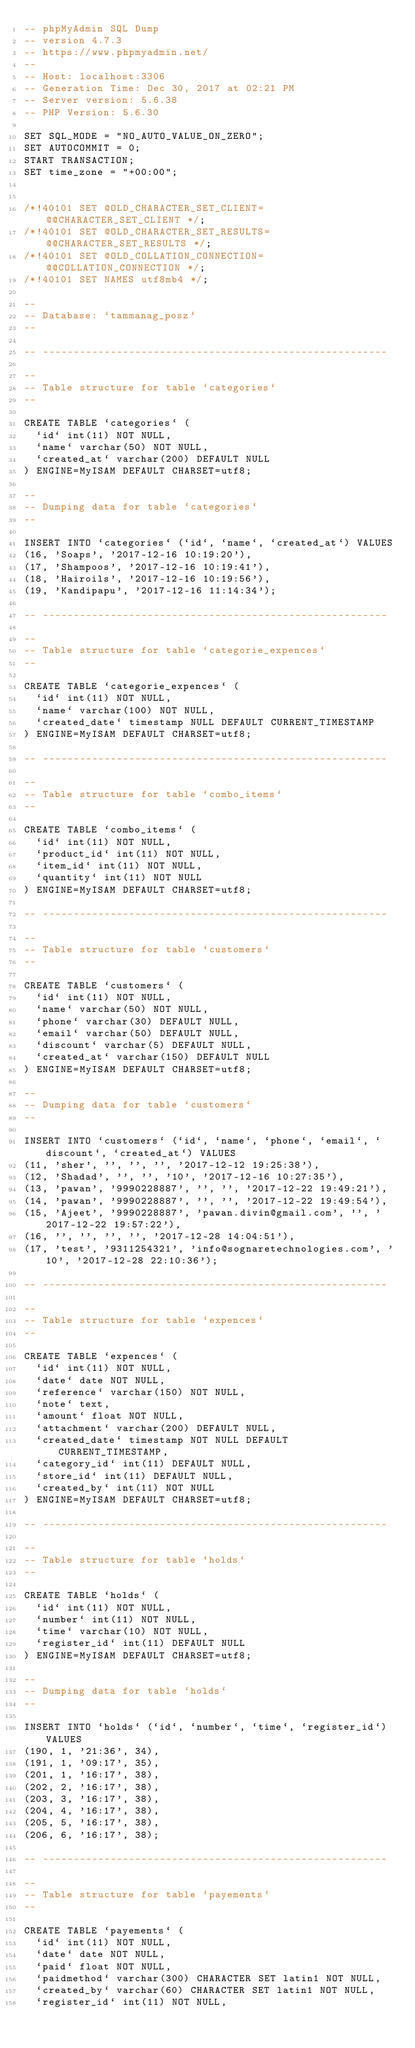<code> <loc_0><loc_0><loc_500><loc_500><_SQL_>-- phpMyAdmin SQL Dump
-- version 4.7.3
-- https://www.phpmyadmin.net/
--
-- Host: localhost:3306
-- Generation Time: Dec 30, 2017 at 02:21 PM
-- Server version: 5.6.38
-- PHP Version: 5.6.30

SET SQL_MODE = "NO_AUTO_VALUE_ON_ZERO";
SET AUTOCOMMIT = 0;
START TRANSACTION;
SET time_zone = "+00:00";


/*!40101 SET @OLD_CHARACTER_SET_CLIENT=@@CHARACTER_SET_CLIENT */;
/*!40101 SET @OLD_CHARACTER_SET_RESULTS=@@CHARACTER_SET_RESULTS */;
/*!40101 SET @OLD_COLLATION_CONNECTION=@@COLLATION_CONNECTION */;
/*!40101 SET NAMES utf8mb4 */;

--
-- Database: `tammanag_posz`
--

-- --------------------------------------------------------

--
-- Table structure for table `categories`
--

CREATE TABLE `categories` (
  `id` int(11) NOT NULL,
  `name` varchar(50) NOT NULL,
  `created_at` varchar(200) DEFAULT NULL
) ENGINE=MyISAM DEFAULT CHARSET=utf8;

--
-- Dumping data for table `categories`
--

INSERT INTO `categories` (`id`, `name`, `created_at`) VALUES
(16, 'Soaps', '2017-12-16 10:19:20'),
(17, 'Shampoos', '2017-12-16 10:19:41'),
(18, 'Hairoils', '2017-12-16 10:19:56'),
(19, 'Kandipapu', '2017-12-16 11:14:34');

-- --------------------------------------------------------

--
-- Table structure for table `categorie_expences`
--

CREATE TABLE `categorie_expences` (
  `id` int(11) NOT NULL,
  `name` varchar(100) NOT NULL,
  `created_date` timestamp NULL DEFAULT CURRENT_TIMESTAMP
) ENGINE=MyISAM DEFAULT CHARSET=utf8;

-- --------------------------------------------------------

--
-- Table structure for table `combo_items`
--

CREATE TABLE `combo_items` (
  `id` int(11) NOT NULL,
  `product_id` int(11) NOT NULL,
  `item_id` int(11) NOT NULL,
  `quantity` int(11) NOT NULL
) ENGINE=MyISAM DEFAULT CHARSET=utf8;

-- --------------------------------------------------------

--
-- Table structure for table `customers`
--

CREATE TABLE `customers` (
  `id` int(11) NOT NULL,
  `name` varchar(50) NOT NULL,
  `phone` varchar(30) DEFAULT NULL,
  `email` varchar(50) DEFAULT NULL,
  `discount` varchar(5) DEFAULT NULL,
  `created_at` varchar(150) DEFAULT NULL
) ENGINE=MyISAM DEFAULT CHARSET=utf8;

--
-- Dumping data for table `customers`
--

INSERT INTO `customers` (`id`, `name`, `phone`, `email`, `discount`, `created_at`) VALUES
(11, 'sher', '', '', '', '2017-12-12 19:25:38'),
(12, 'Shadad', '', '', '10', '2017-12-16 10:27:35'),
(13, 'pawan', '9990228887', '', '', '2017-12-22 19:49:21'),
(14, 'pawan', '9990228887', '', '', '2017-12-22 19:49:54'),
(15, 'Ajeet', '9990228887', 'pawan.divin@gmail.com', '', '2017-12-22 19:57:22'),
(16, '', '', '', '', '2017-12-28 14:04:51'),
(17, 'test', '9311254321', 'info@sognaretechnologies.com', '10', '2017-12-28 22:10:36');

-- --------------------------------------------------------

--
-- Table structure for table `expences`
--

CREATE TABLE `expences` (
  `id` int(11) NOT NULL,
  `date` date NOT NULL,
  `reference` varchar(150) NOT NULL,
  `note` text,
  `amount` float NOT NULL,
  `attachment` varchar(200) DEFAULT NULL,
  `created_date` timestamp NOT NULL DEFAULT CURRENT_TIMESTAMP,
  `category_id` int(11) DEFAULT NULL,
  `store_id` int(11) DEFAULT NULL,
  `created_by` int(11) NOT NULL
) ENGINE=MyISAM DEFAULT CHARSET=utf8;

-- --------------------------------------------------------

--
-- Table structure for table `holds`
--

CREATE TABLE `holds` (
  `id` int(11) NOT NULL,
  `number` int(11) NOT NULL,
  `time` varchar(10) NOT NULL,
  `register_id` int(11) DEFAULT NULL
) ENGINE=MyISAM DEFAULT CHARSET=utf8;

--
-- Dumping data for table `holds`
--

INSERT INTO `holds` (`id`, `number`, `time`, `register_id`) VALUES
(190, 1, '21:36', 34),
(191, 1, '09:17', 35),
(201, 1, '16:17', 38),
(202, 2, '16:17', 38),
(203, 3, '16:17', 38),
(204, 4, '16:17', 38),
(205, 5, '16:17', 38),
(206, 6, '16:17', 38);

-- --------------------------------------------------------

--
-- Table structure for table `payements`
--

CREATE TABLE `payements` (
  `id` int(11) NOT NULL,
  `date` date NOT NULL,
  `paid` float NOT NULL,
  `paidmethod` varchar(300) CHARACTER SET latin1 NOT NULL,
  `created_by` varchar(60) CHARACTER SET latin1 NOT NULL,
  `register_id` int(11) NOT NULL,</code> 